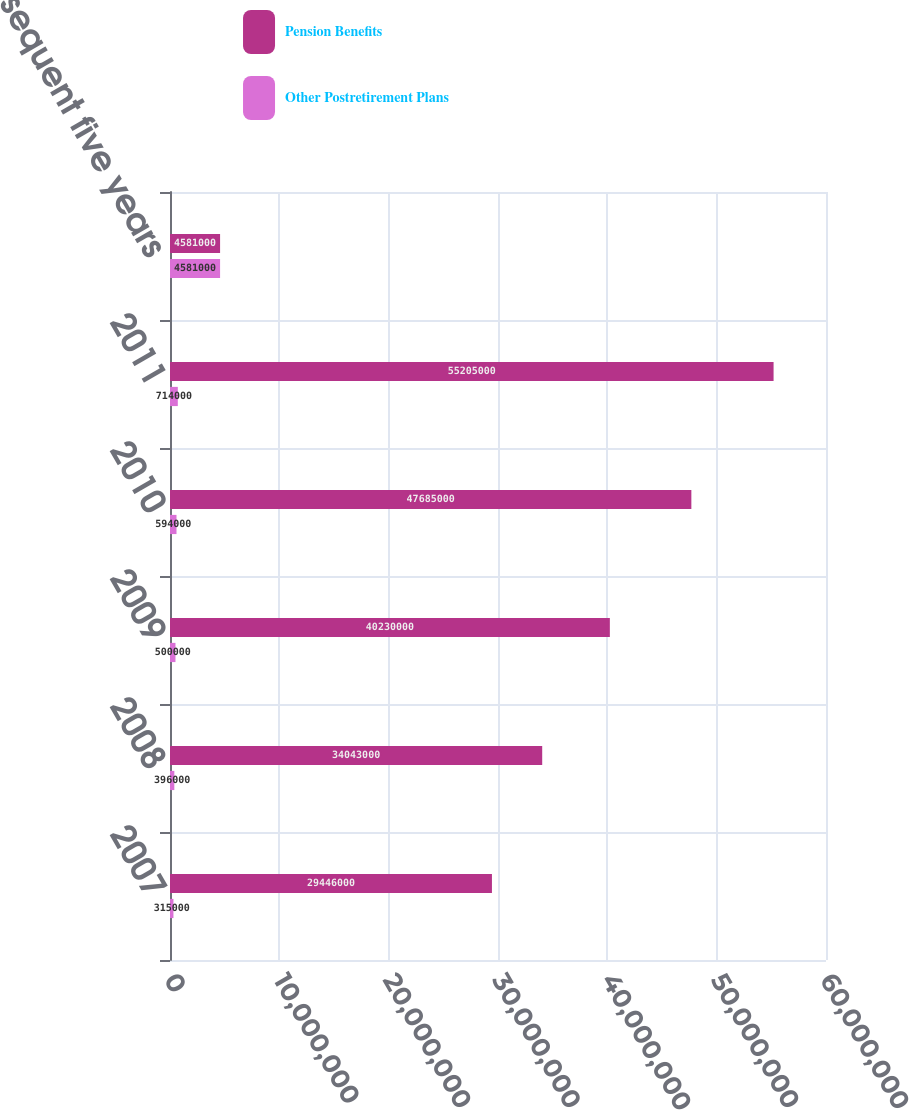Convert chart to OTSL. <chart><loc_0><loc_0><loc_500><loc_500><stacked_bar_chart><ecel><fcel>2007<fcel>2008<fcel>2009<fcel>2010<fcel>2011<fcel>Subsequent five years<nl><fcel>Pension Benefits<fcel>2.9446e+07<fcel>3.4043e+07<fcel>4.023e+07<fcel>4.7685e+07<fcel>5.5205e+07<fcel>4.581e+06<nl><fcel>Other Postretirement Plans<fcel>315000<fcel>396000<fcel>500000<fcel>594000<fcel>714000<fcel>4.581e+06<nl></chart> 